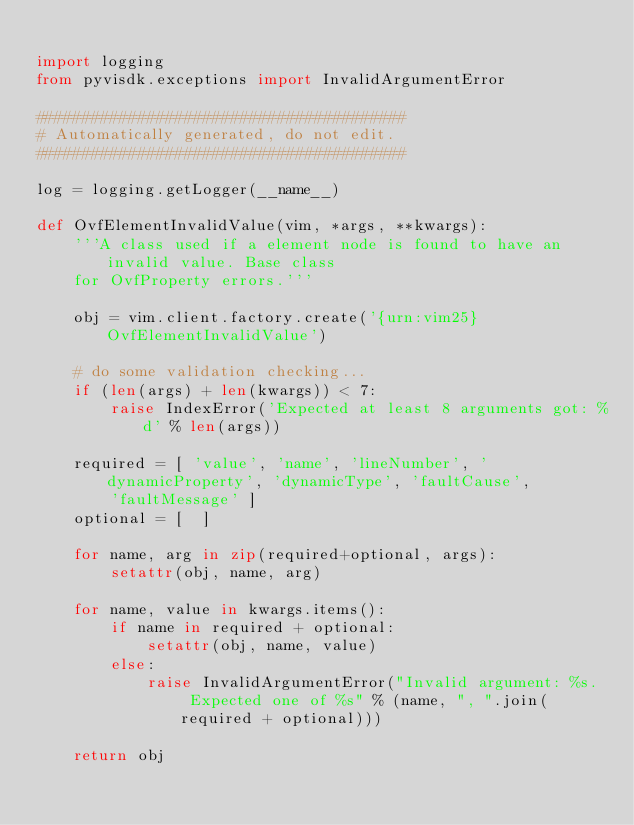<code> <loc_0><loc_0><loc_500><loc_500><_Python_>
import logging
from pyvisdk.exceptions import InvalidArgumentError

########################################
# Automatically generated, do not edit.
########################################

log = logging.getLogger(__name__)

def OvfElementInvalidValue(vim, *args, **kwargs):
    '''A class used if a element node is found to have an invalid value. Base class
    for OvfProperty errors.'''

    obj = vim.client.factory.create('{urn:vim25}OvfElementInvalidValue')

    # do some validation checking...
    if (len(args) + len(kwargs)) < 7:
        raise IndexError('Expected at least 8 arguments got: %d' % len(args))

    required = [ 'value', 'name', 'lineNumber', 'dynamicProperty', 'dynamicType', 'faultCause',
        'faultMessage' ]
    optional = [  ]

    for name, arg in zip(required+optional, args):
        setattr(obj, name, arg)

    for name, value in kwargs.items():
        if name in required + optional:
            setattr(obj, name, value)
        else:
            raise InvalidArgumentError("Invalid argument: %s.  Expected one of %s" % (name, ", ".join(required + optional)))

    return obj
</code> 